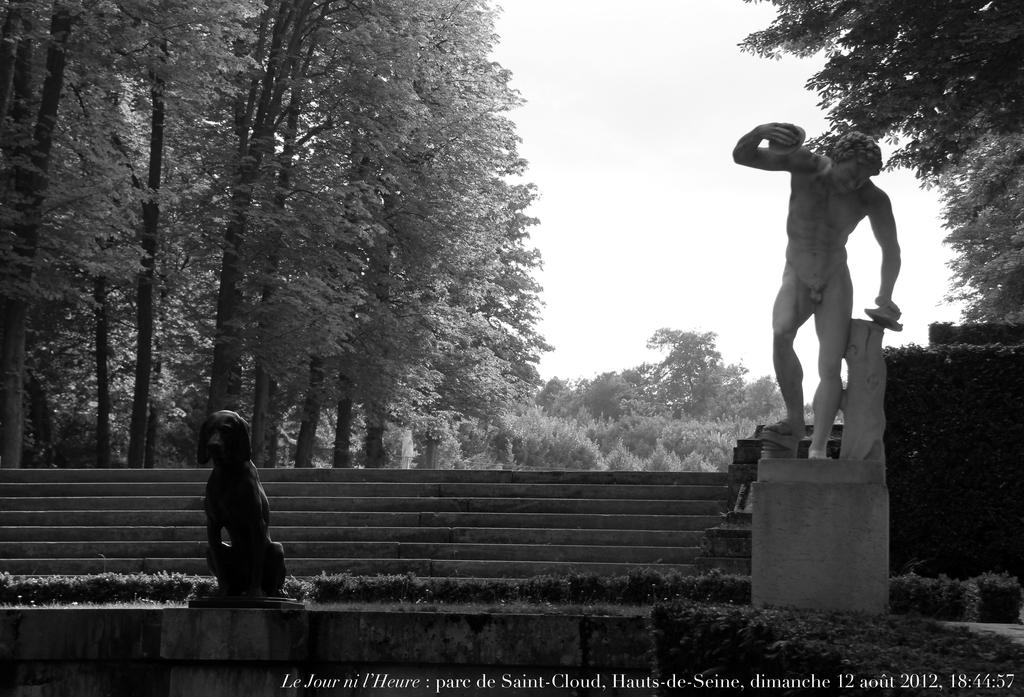What is the main subject in the image? There is a statue in the image. What architectural feature is present in the image? There are steps in the image. What type of natural elements can be seen in the image? There are trees in the image. What is visible in the background of the image? The sky is visible in the image. What type of cart is being used to solve arithmetic problems in the image? There is no cart or arithmetic problems present in the image. 